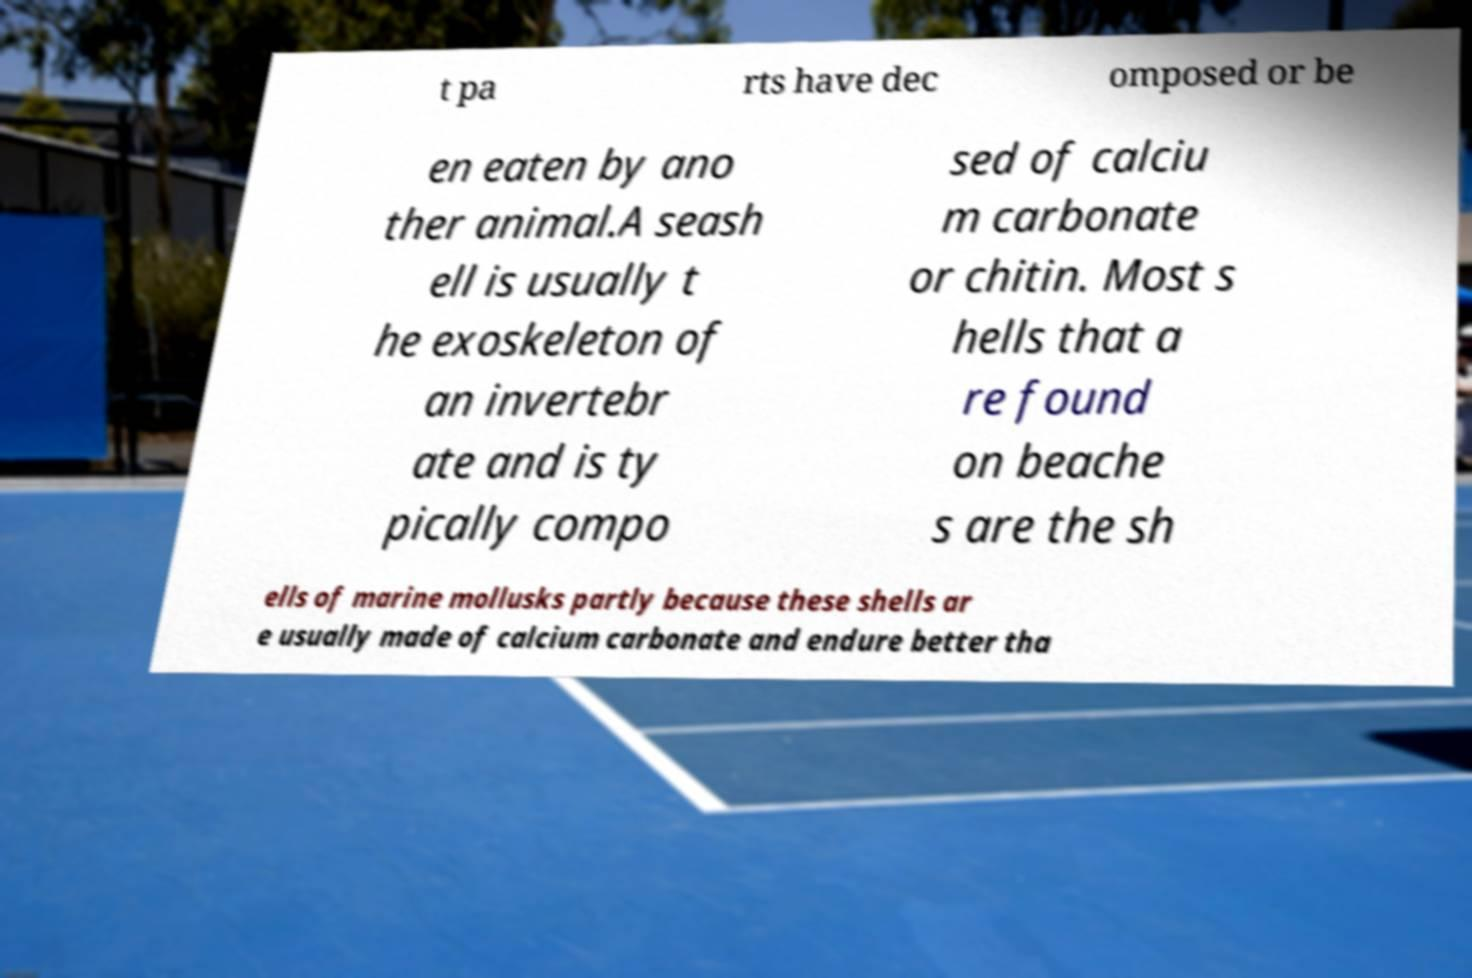What messages or text are displayed in this image? I need them in a readable, typed format. t pa rts have dec omposed or be en eaten by ano ther animal.A seash ell is usually t he exoskeleton of an invertebr ate and is ty pically compo sed of calciu m carbonate or chitin. Most s hells that a re found on beache s are the sh ells of marine mollusks partly because these shells ar e usually made of calcium carbonate and endure better tha 